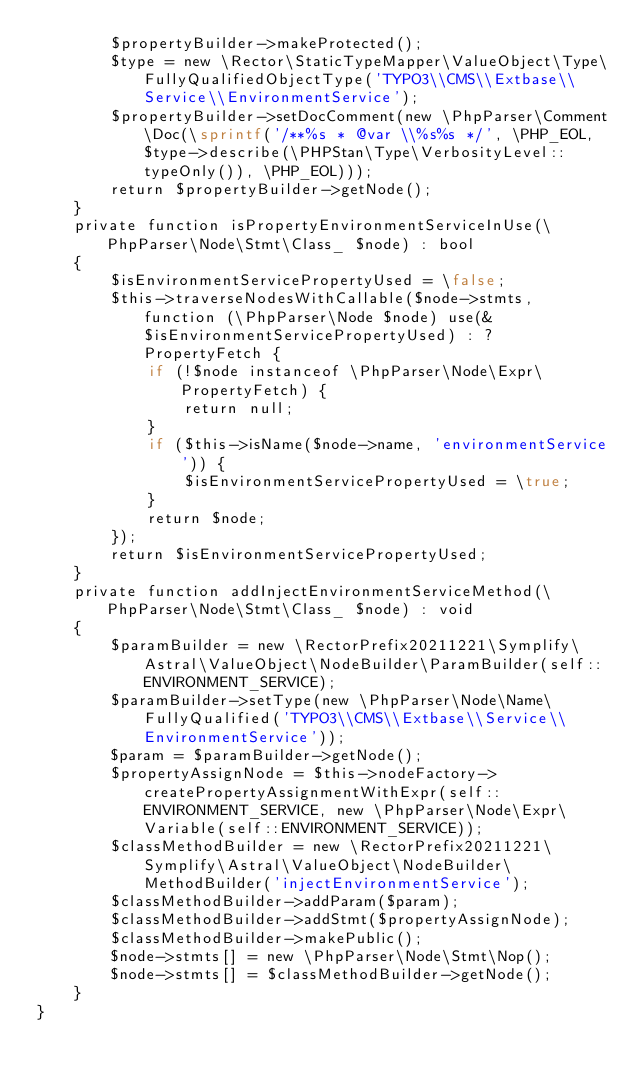Convert code to text. <code><loc_0><loc_0><loc_500><loc_500><_PHP_>        $propertyBuilder->makeProtected();
        $type = new \Rector\StaticTypeMapper\ValueObject\Type\FullyQualifiedObjectType('TYPO3\\CMS\\Extbase\\Service\\EnvironmentService');
        $propertyBuilder->setDocComment(new \PhpParser\Comment\Doc(\sprintf('/**%s * @var \\%s%s */', \PHP_EOL, $type->describe(\PHPStan\Type\VerbosityLevel::typeOnly()), \PHP_EOL)));
        return $propertyBuilder->getNode();
    }
    private function isPropertyEnvironmentServiceInUse(\PhpParser\Node\Stmt\Class_ $node) : bool
    {
        $isEnvironmentServicePropertyUsed = \false;
        $this->traverseNodesWithCallable($node->stmts, function (\PhpParser\Node $node) use(&$isEnvironmentServicePropertyUsed) : ?PropertyFetch {
            if (!$node instanceof \PhpParser\Node\Expr\PropertyFetch) {
                return null;
            }
            if ($this->isName($node->name, 'environmentService')) {
                $isEnvironmentServicePropertyUsed = \true;
            }
            return $node;
        });
        return $isEnvironmentServicePropertyUsed;
    }
    private function addInjectEnvironmentServiceMethod(\PhpParser\Node\Stmt\Class_ $node) : void
    {
        $paramBuilder = new \RectorPrefix20211221\Symplify\Astral\ValueObject\NodeBuilder\ParamBuilder(self::ENVIRONMENT_SERVICE);
        $paramBuilder->setType(new \PhpParser\Node\Name\FullyQualified('TYPO3\\CMS\\Extbase\\Service\\EnvironmentService'));
        $param = $paramBuilder->getNode();
        $propertyAssignNode = $this->nodeFactory->createPropertyAssignmentWithExpr(self::ENVIRONMENT_SERVICE, new \PhpParser\Node\Expr\Variable(self::ENVIRONMENT_SERVICE));
        $classMethodBuilder = new \RectorPrefix20211221\Symplify\Astral\ValueObject\NodeBuilder\MethodBuilder('injectEnvironmentService');
        $classMethodBuilder->addParam($param);
        $classMethodBuilder->addStmt($propertyAssignNode);
        $classMethodBuilder->makePublic();
        $node->stmts[] = new \PhpParser\Node\Stmt\Nop();
        $node->stmts[] = $classMethodBuilder->getNode();
    }
}
</code> 